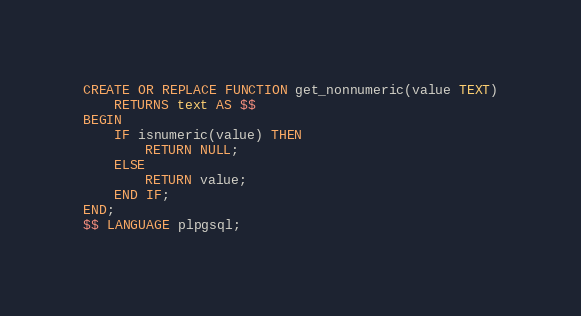Convert code to text. <code><loc_0><loc_0><loc_500><loc_500><_SQL_>CREATE OR REPLACE FUNCTION get_nonnumeric(value TEXT)
	RETURNS text AS $$
BEGIN
    IF isnumeric(value) THEN
        RETURN NULL;
    ELSE
        RETURN value;
    END IF;
END;
$$ LANGUAGE plpgsql;</code> 